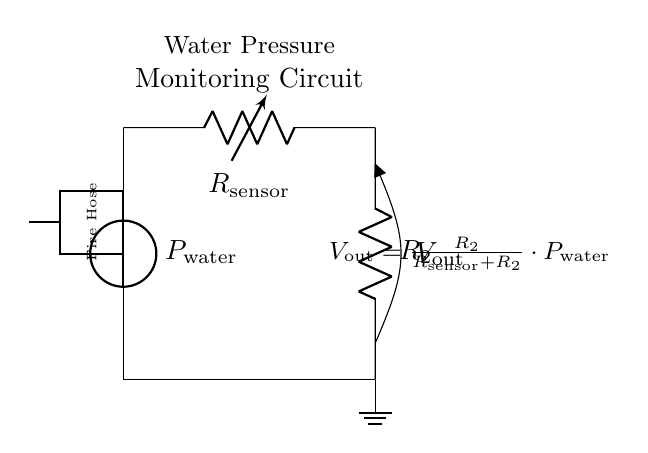What is the type of circuit depicted? The circuit is a voltage divider circuit, which is evident from the arrangement of the resistors in series and the output voltage being taken from one of the resistors.
Answer: Voltage divider What is the variable resistor representing? The variable resistor represents the pressure sensor which adjusts its resistance based on water pressure, indicated by the label R_sensor in the diagram.
Answer: Pressure sensor What is the formula for the output voltage? The formula shown in the circuit for the output voltage is V_out = R_2 / (R_sensor + R_2) * P_water, indicating that the output voltage is derived from the resistance values and input pressure.
Answer: V_out = R_2 / (R_sensor + R_2) * P_water What does the voltage V_out measure? V_out measures the voltage drop across resistor R_2, which is proportional to the water pressure, as indicated by its placement in the output section of the voltage divider.
Answer: Voltage drop across R_2 How are the resistors connected in the circuit? The resistors are connected in series, as shown by the continuous path from R_sensor to R_2, confirming that the voltage is shared across them.
Answer: In series What does a higher water pressure do to V_out? A higher water pressure increases V_out, since the output voltage is directly proportional to P_water in the voltage divider formula.
Answer: Increases V_out 